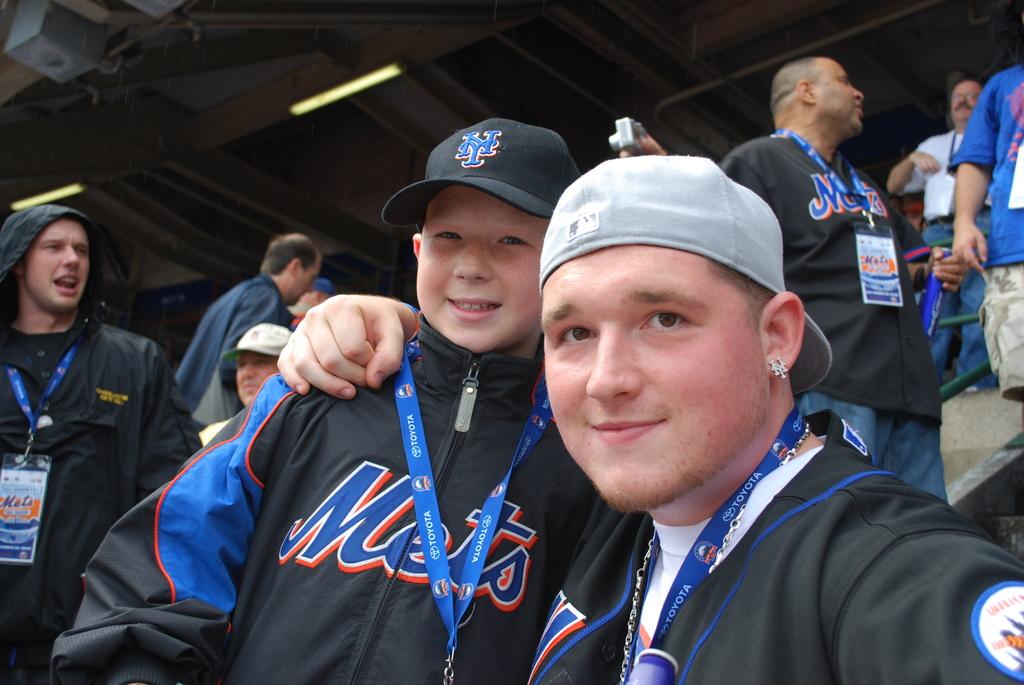What team are they rooting for?
Provide a succinct answer. Mets. What letters are on the black hat?
Ensure brevity in your answer.  Ny. 